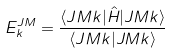Convert formula to latex. <formula><loc_0><loc_0><loc_500><loc_500>E ^ { J M } _ { k } = \frac { \langle J M k | \hat { H } | J M k \rangle } { \langle J M k | J M k \rangle }</formula> 